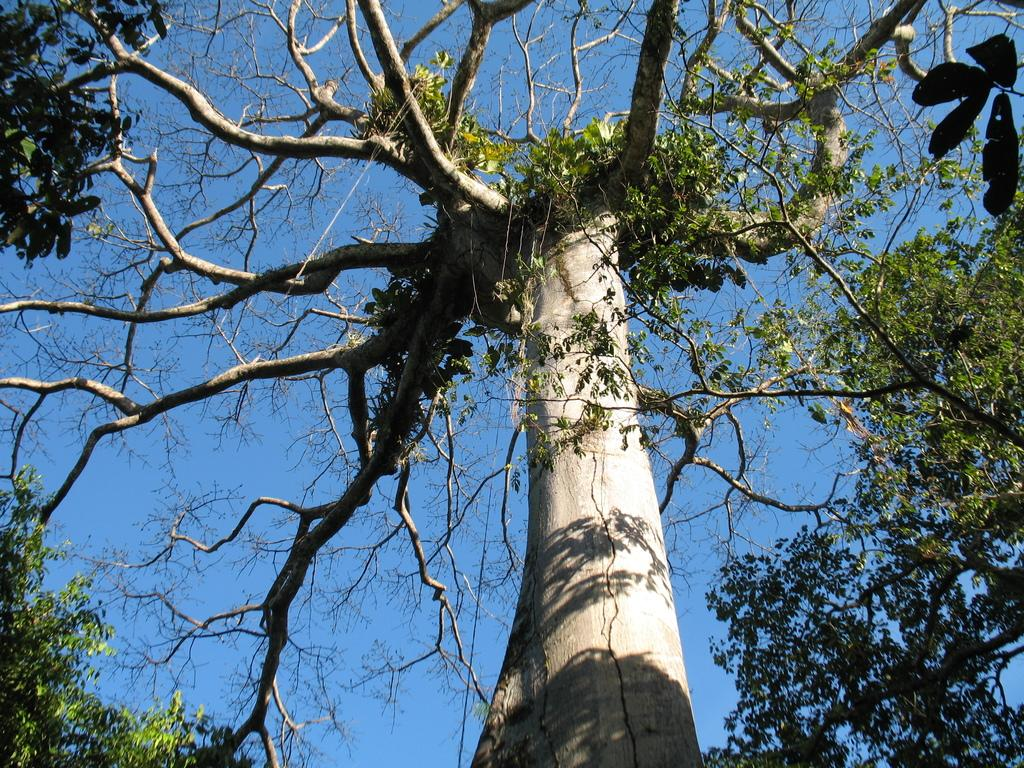What is the main object in the picture? There is a tree in the picture. What can be observed about the tree? The tree has leaves on it. What else is visible in the picture besides the tree? The sky is visible in the picture. What is the color of the sky in the picture? The sky is blue in color. Where is the stream of coal located in the picture? There is no stream of coal present in the picture. What type of lip can be seen on the tree in the picture? There are no lips present on the tree in the picture. 